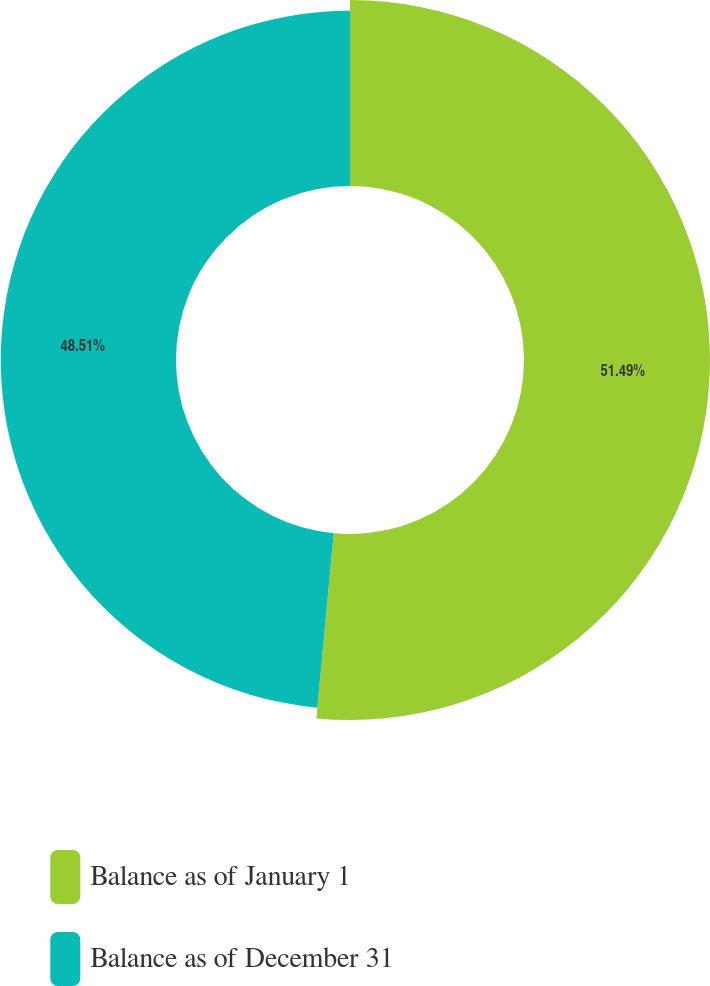<chart> <loc_0><loc_0><loc_500><loc_500><pie_chart><fcel>Balance as of January 1<fcel>Balance as of December 31<nl><fcel>51.49%<fcel>48.51%<nl></chart> 